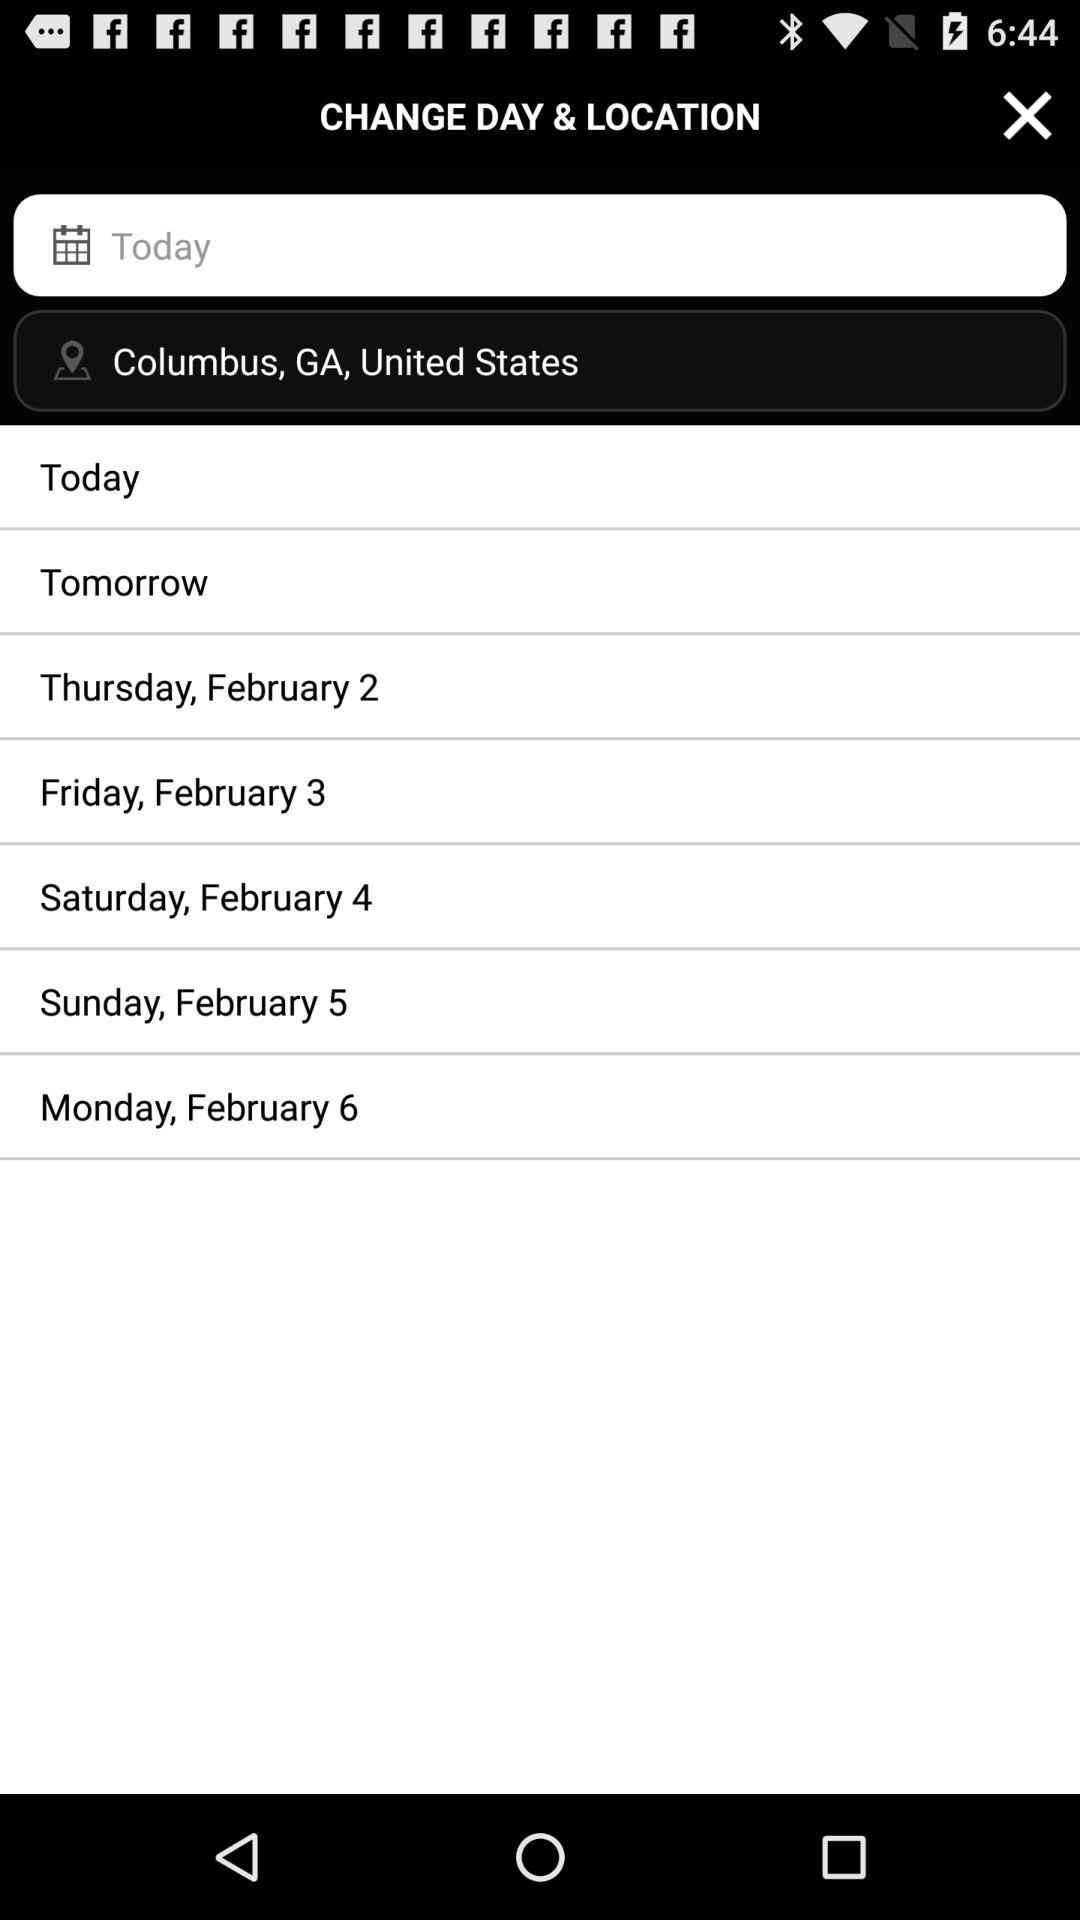How many days are after today?
Answer the question using a single word or phrase. 6 